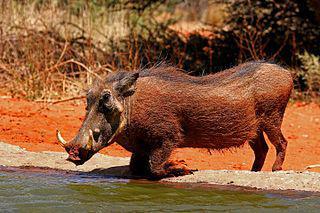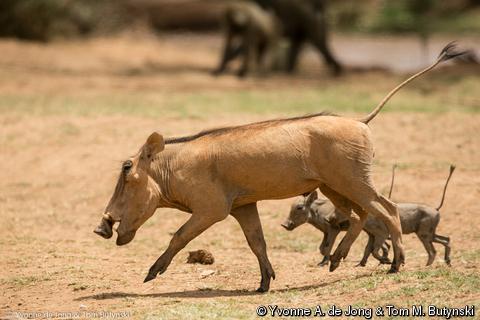The first image is the image on the left, the second image is the image on the right. Evaluate the accuracy of this statement regarding the images: "A hog is near a body of water.". Is it true? Answer yes or no. Yes. The first image is the image on the left, the second image is the image on the right. Analyze the images presented: Is the assertion "An image shows at least one warthog in profile, running across a dry field with its tail flying out behind it." valid? Answer yes or no. Yes. 